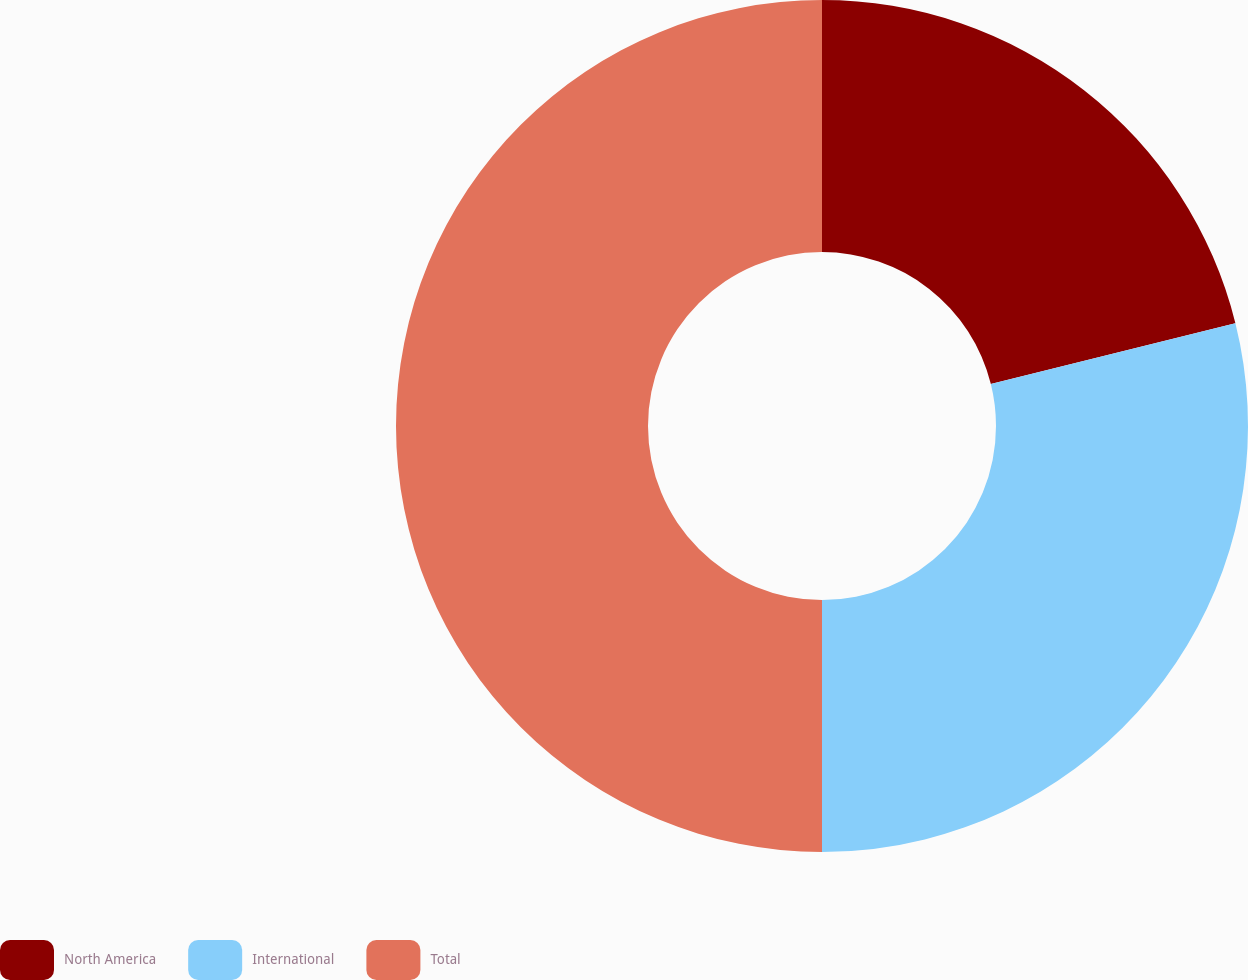<chart> <loc_0><loc_0><loc_500><loc_500><pie_chart><fcel>North America<fcel>International<fcel>Total<nl><fcel>21.12%<fcel>28.88%<fcel>50.0%<nl></chart> 